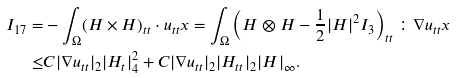Convert formula to latex. <formula><loc_0><loc_0><loc_500><loc_500>I _ { 1 7 } = & - \int _ { \Omega } ( H \times H ) _ { t t } \cdot u _ { t t } x = \int _ { \Omega } \left ( H \otimes H - \frac { 1 } { 2 } | H | ^ { 2 } I _ { 3 } \right ) _ { t t } \colon \nabla u _ { t t } x \\ \leq & C | \nabla u _ { t t } | _ { 2 } | H _ { t } | ^ { 2 } _ { 4 } + C | \nabla u _ { t t } | _ { 2 } | H _ { t t } | _ { 2 } | H | _ { \infty } .</formula> 